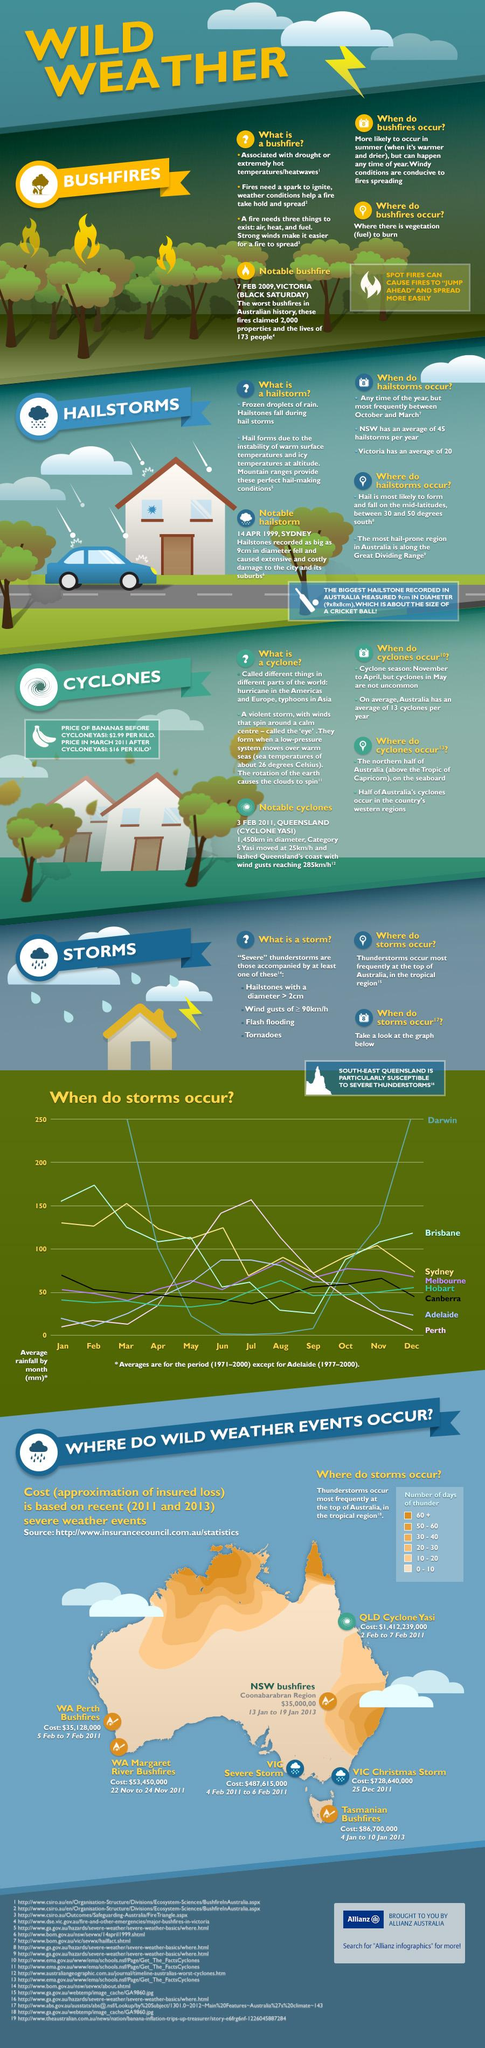Outline some significant characteristics in this image. According to studies, the city of Darwin in Australia experiences the highest peak of thunderstorms. It is currently experiencing an unusually high number of days with thunder in the tropical region of Australia, with the number exceeding 60. Sydney typically experiences the highest number of storms in March. The highest number of storms occurs in August in Hobart. The cost of the severe storm in the state of Victoria was $487,615,000. 